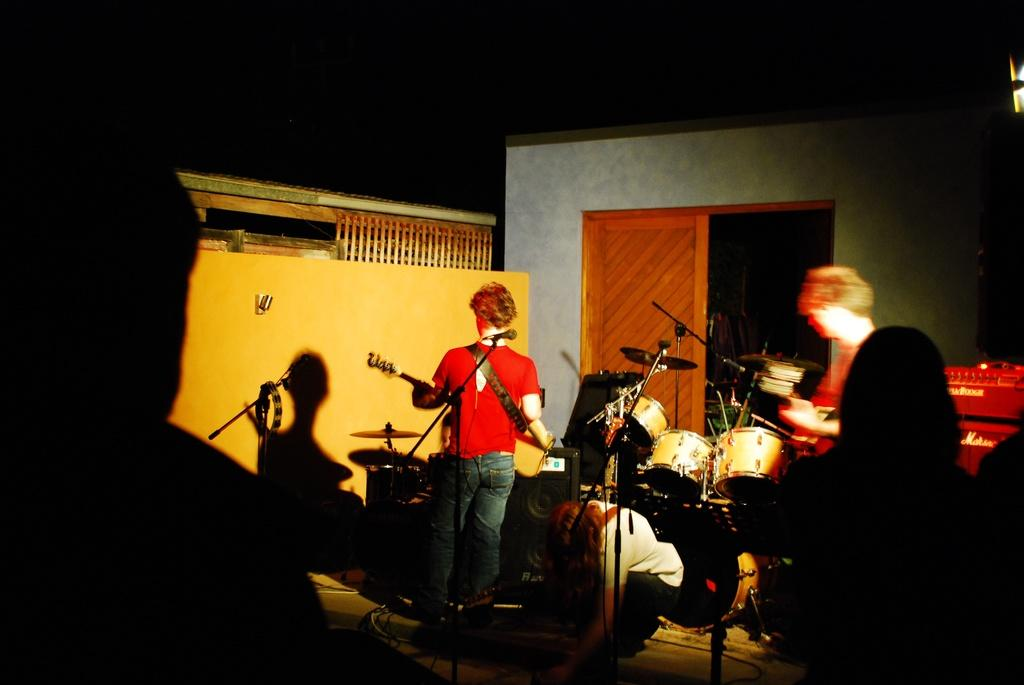What type of group is present in the image? There is a music band in the image. What are the members of the band doing? Each member of the band is playing a musical instrument. What can be seen in the background of the image? There is a wall and a door in the background of the image. Where is the throne located in the image? There is no throne present in the image. What type of food is being served on the table in the image? There is no table or food visible in the image. 